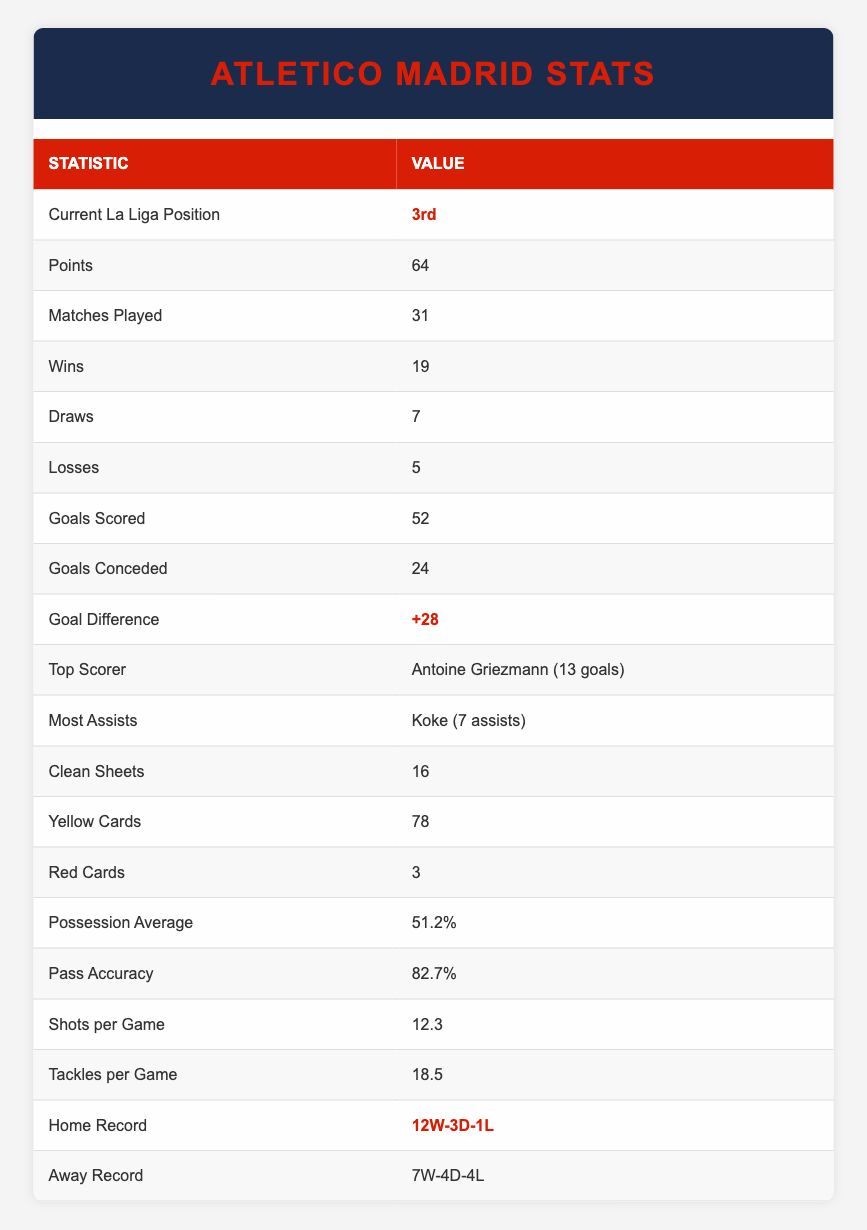What is Atletico Madrid's current La Liga position? The table clearly states that Atletico Madrid is currently in the 3rd position in La Liga.
Answer: 3rd How many points does Atletico Madrid have this season? According to the table, Atletico Madrid has accumulated a total of 64 points this season.
Answer: 64 Who is Atletico Madrid's top scorer? The table indicates that Antoine Griezmann is the top scorer for the team with 13 goals.
Answer: Antoine Griezmann (13 goals) What is Atletico Madrid's goal difference? The goal difference is given in the table as +28, calculated as Goals Scored (52) minus Goals Conceded (24).
Answer: +28 Does Atletico Madrid have more wins than losses this season? By comparing the number of wins (19) and losses (5) from the table, it's clear that the team has significantly more wins than losses, confirming a yes.
Answer: Yes What percentage of possession does Atletico Madrid average? The table shows that Atletico Madrid has an average possession of 51.2% during their matches this season.
Answer: 51.2% How many more clean sheets does Atletico Madrid have than red cards? The table shows that Atletico has 16 clean sheets and 3 red cards. The difference is calculated as 16 - 3 = 13.
Answer: 13 What is Atletico Madrid's away record this season? The table records Atletico Madrid's away performance as 7 Wins, 4 Draws, and 4 Losses (7W-4D-4L).
Answer: 7W-4D-4L How many goals has Koke contributed through assists this season? The table indicates that Koke has provided 7 assists for the team this season.
Answer: 7 assists 